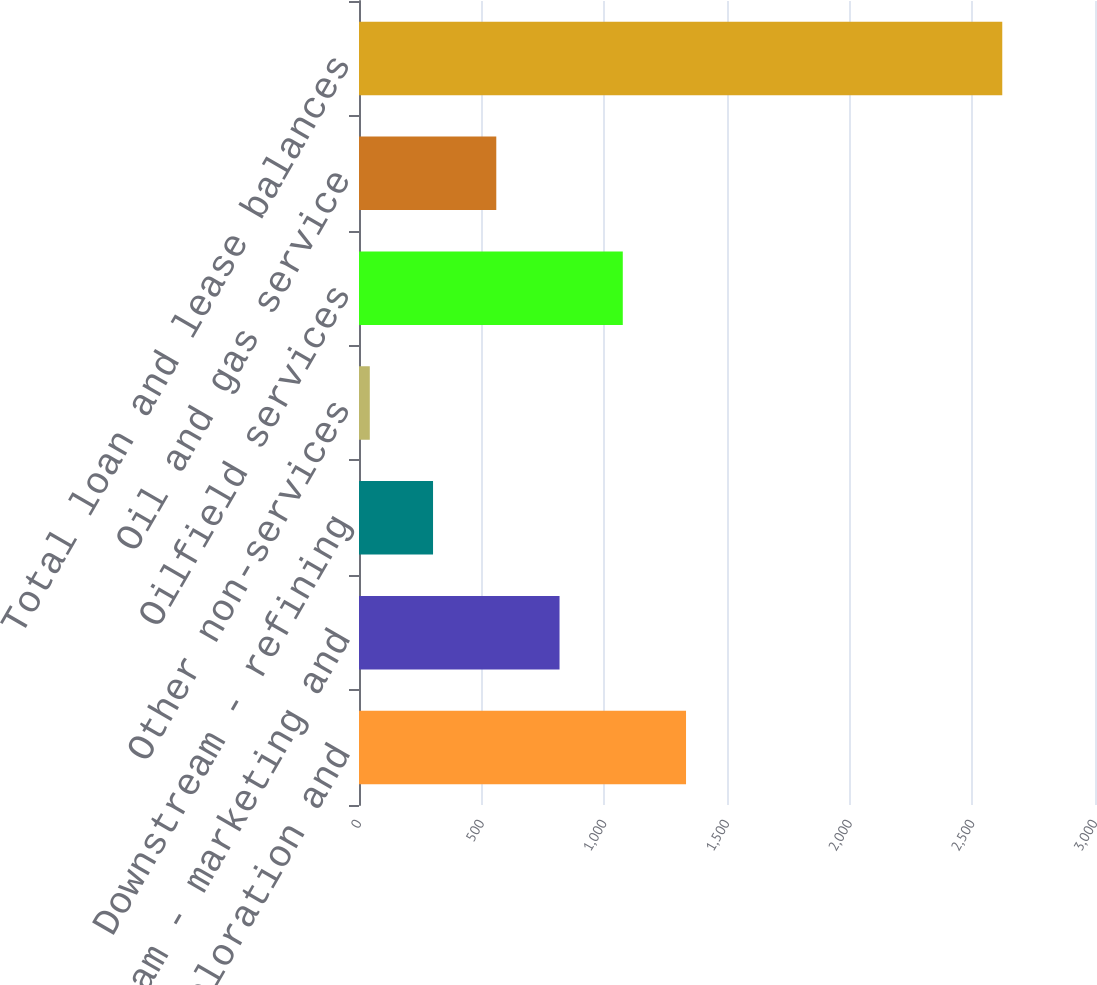Convert chart to OTSL. <chart><loc_0><loc_0><loc_500><loc_500><bar_chart><fcel>Upstream - exploration and<fcel>Midstream - marketing and<fcel>Downstream - refining<fcel>Other non-services<fcel>Oilfield services<fcel>Oil and gas service<fcel>Total loan and lease balances<nl><fcel>1333<fcel>817.4<fcel>301.8<fcel>44<fcel>1075.2<fcel>559.6<fcel>2622<nl></chart> 